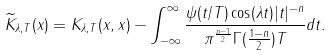<formula> <loc_0><loc_0><loc_500><loc_500>\widetilde { K } _ { \lambda , T } ( x ) = K _ { \lambda , T } ( x , x ) - \int _ { - \infty } ^ { \infty } \frac { \psi ( t / T ) \cos ( \lambda t ) | t | ^ { - n } } { \pi ^ { \frac { n - 1 } { 2 } } \Gamma ( \frac { 1 - n } { 2 } ) T } d t .</formula> 